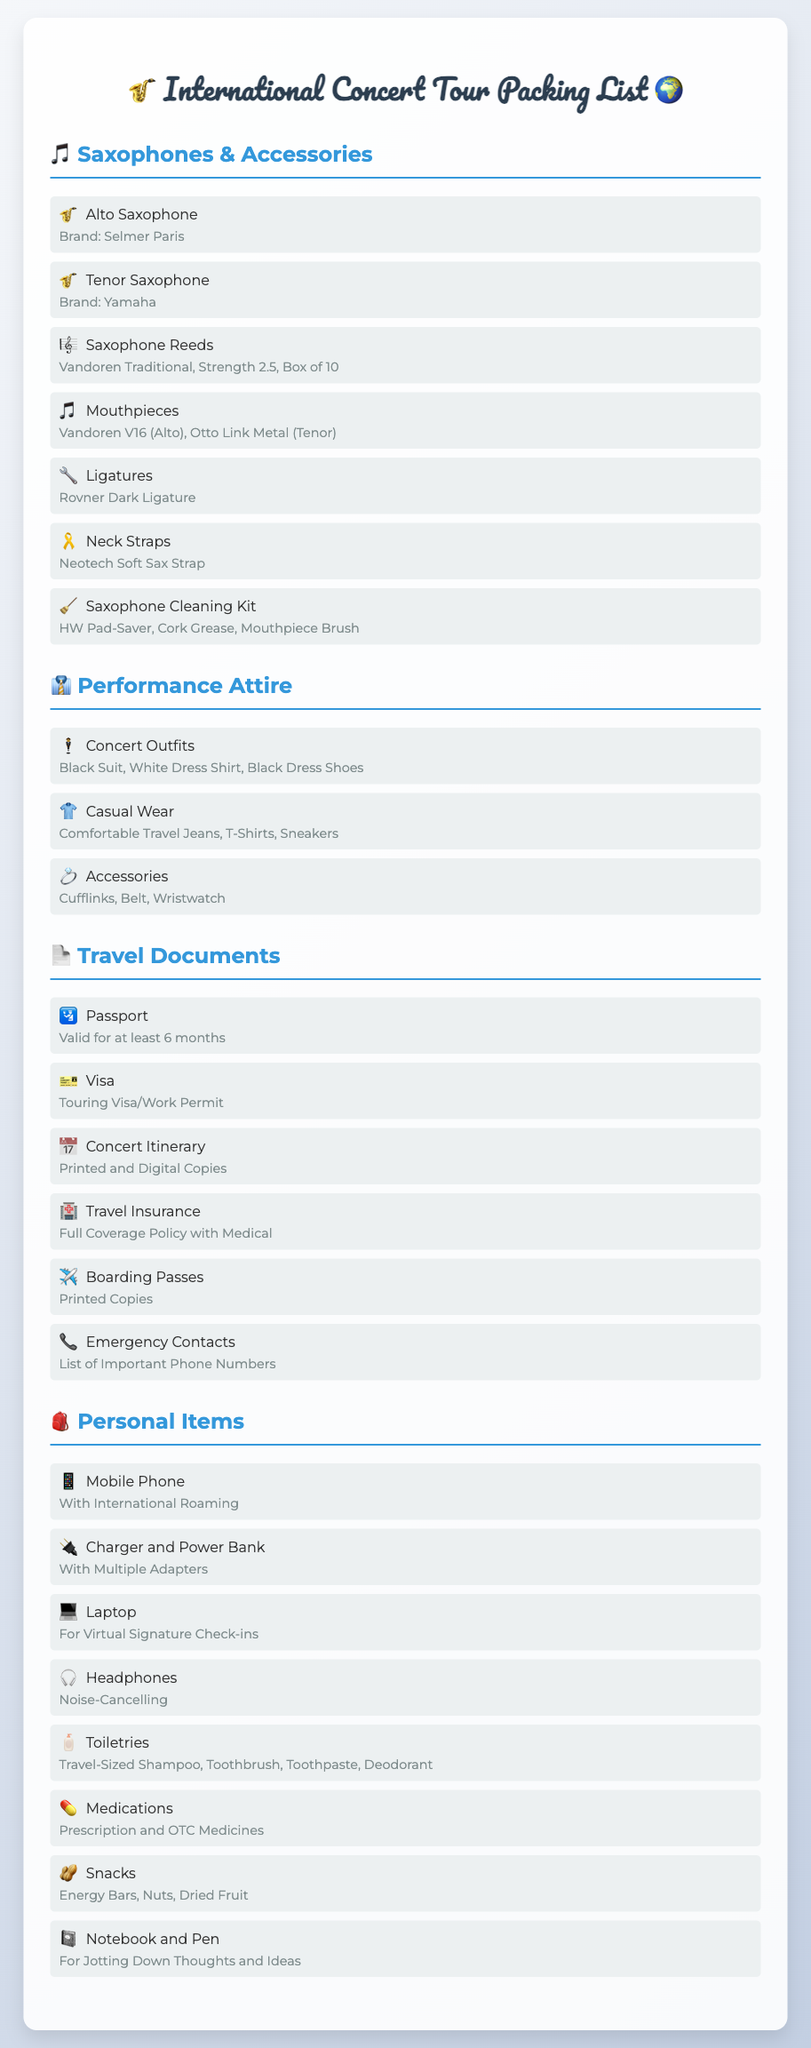What types of saxophones are included? The document lists two types of saxophones: Alto Saxophone and Tenor Saxophone.
Answer: Alto Saxophone and Tenor Saxophone How many reeds are in a box? The document specifies that the box contains 10 reeds.
Answer: Box of 10 What is the brand of the Alto Saxophone? The document mentions that the Alto Saxophone is from Selmer Paris.
Answer: Selmer Paris What is required for travel insurance? The travel insurance must have full coverage policy with medical.
Answer: Full Coverage Policy with Medical What is included in the performance attire? The performance attire includes a black suit, white dress shirt, and black dress shoes.
Answer: Black Suit, White Dress Shirt, Black Dress Shoes How many adapters are mentioned for the charger? The document specifies that the charger should come with multiple adapters.
Answer: Multiple Adapters What type of headphones are recommended? The document suggests using noise-cancelling headphones.
Answer: Noise-Cancelling What should be included in the emergency contacts? The emergency contacts should consist of a list of important phone numbers.
Answer: List of Important Phone Numbers How long must the passport be valid for? The passport must be valid for at least 6 months.
Answer: At least 6 months 